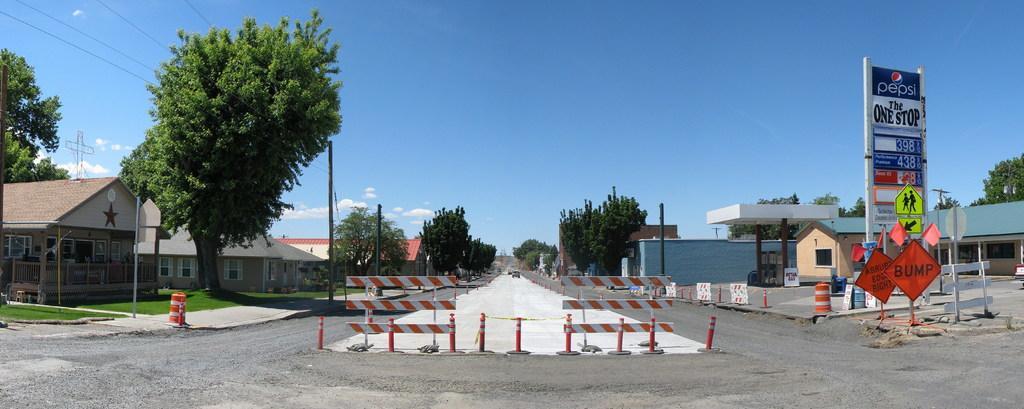Describe this image in one or two sentences. In the center of the image we can see vehicles on road and traffic cones. On the left side of the image we can see trees, poles, houses. On the right side of the image we can see gas station, houses, trees and poles. In the background we can see sky and clouds. 